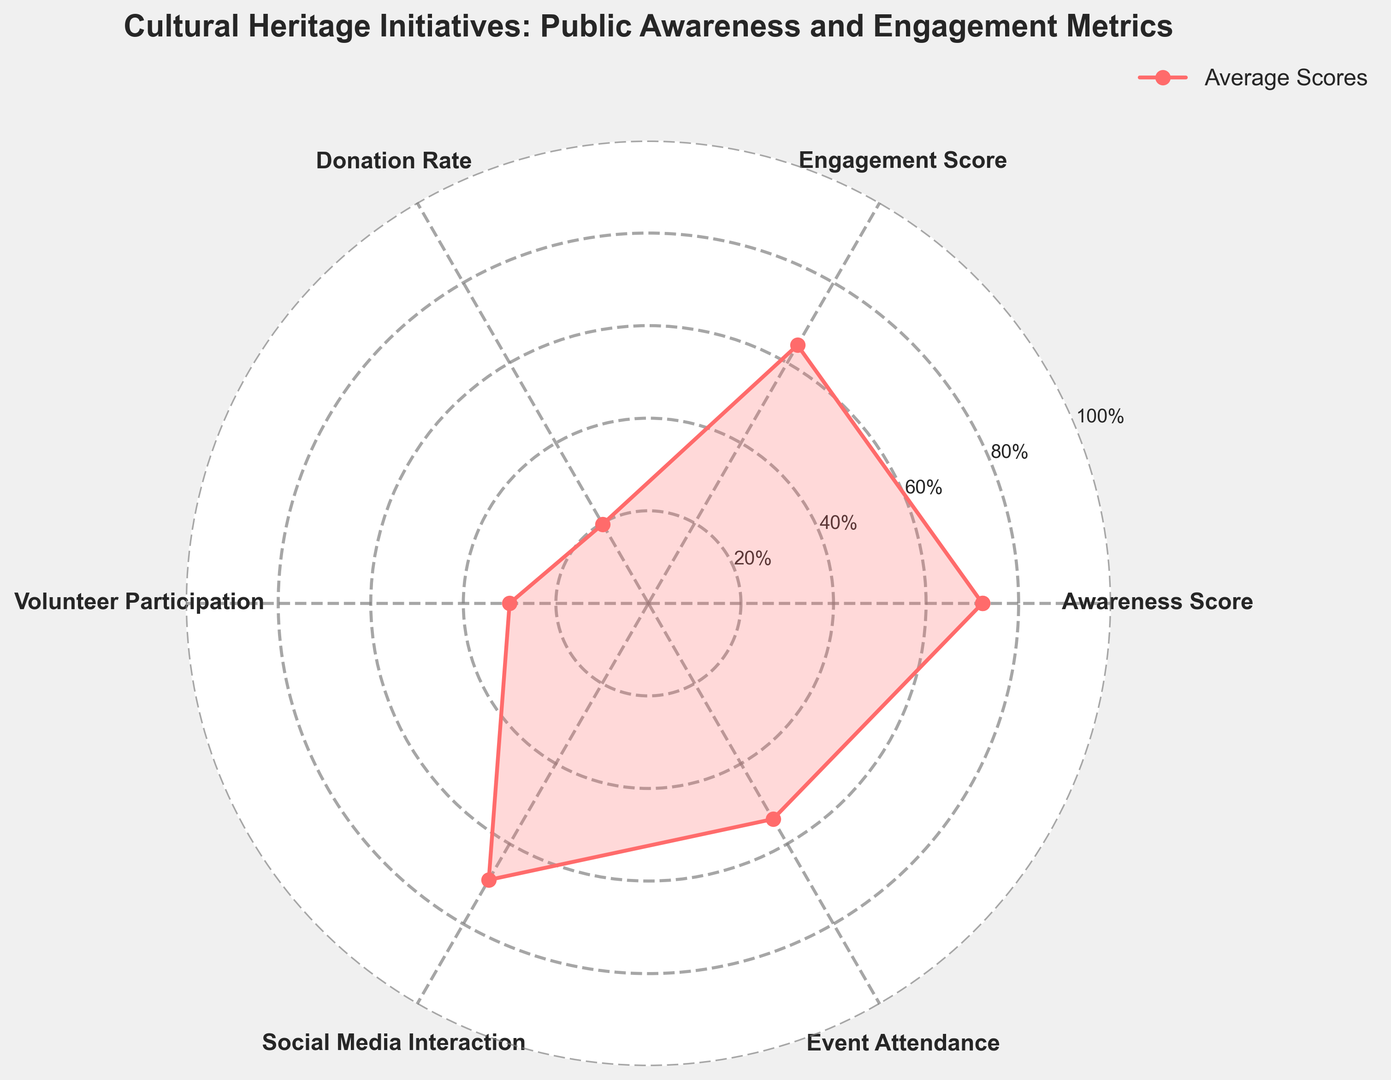What is the average Awareness Score across all the metrics? The figure displays values for six metrics, including Awareness Score. We calculate the average of these values. Awareness Score is plainly given in the data, and to find the average, we sum the values and divide by the number of categories.
Answer: 73.3 How does the Engagement Score compare to the Donation Rate? Looking at the plot, we identify the points for Engagement Score and Donation Rate. We compare their positions within the plot. Engagement Score is noticeably higher than Donation Rate in the radar chart.
Answer: Engagement Score is higher Which metric has the lowest value on average? Examine the radar chart for the lowest point among the plotted values. This corresponds to the Social Media Interaction, which is the lowest among the metrics displayed.
Answer: Social Media Interaction Which age group seems to have the highest level of awareness based on the average values shown? The data indicates the projection of the Awareness Score for various age groups. Considering the average of 85 for the age group '60+', it's clearly the highest compared to others.
Answer: 60+ What is the difference between the highest Event Attendance rate and the highest Donation Rate? Locate the highest values for Event Attendance and Donation Rate on the plot, then compute the difference. Event Attendance peaks at 70 and Donation Rate at 30, thus the difference is 70 - 30.
Answer: 40 Which metric shows more variability, Donation Rate or Social Media Interaction? Compare the spread of Donation Rate and Social Media Interaction across the plot. Social Media Interaction values fluctuate more with a wider range compared to Donation Rate.
Answer: Social Media Interaction Among the countries listed, which has the highest average number of volunteer participants? Analyze the radar chart for Volunteer Participation. The highest point can be seen distinctively for Germany, where Volunteer Participation average reaches 40.
Answer: Germany How often do the Awareness Score and Engagement Score cross paths on the radar chart? Evaluate all points where Awareness Score and Engagement Score data would intersect if plotted directly. They do not intersect on the radar chart as their values are consistently different.
Answer: They do not cross Which country has the lowest Social Media Interaction rate based on visual assessment? Visually inspecting the radar chart, the lowest point for Social Media Interaction would be Brazil, whose mark is around 18.
Answer: Brazil What’s the median value of Event Attendance among the plotted points? List the six Event Attendance values from the radar chart, and determine the middle value. Ordered values are 35, 40, 45, 55, 60, 65. The median is the average of 45 and 55, as they are the two middle values.
Answer: 50 